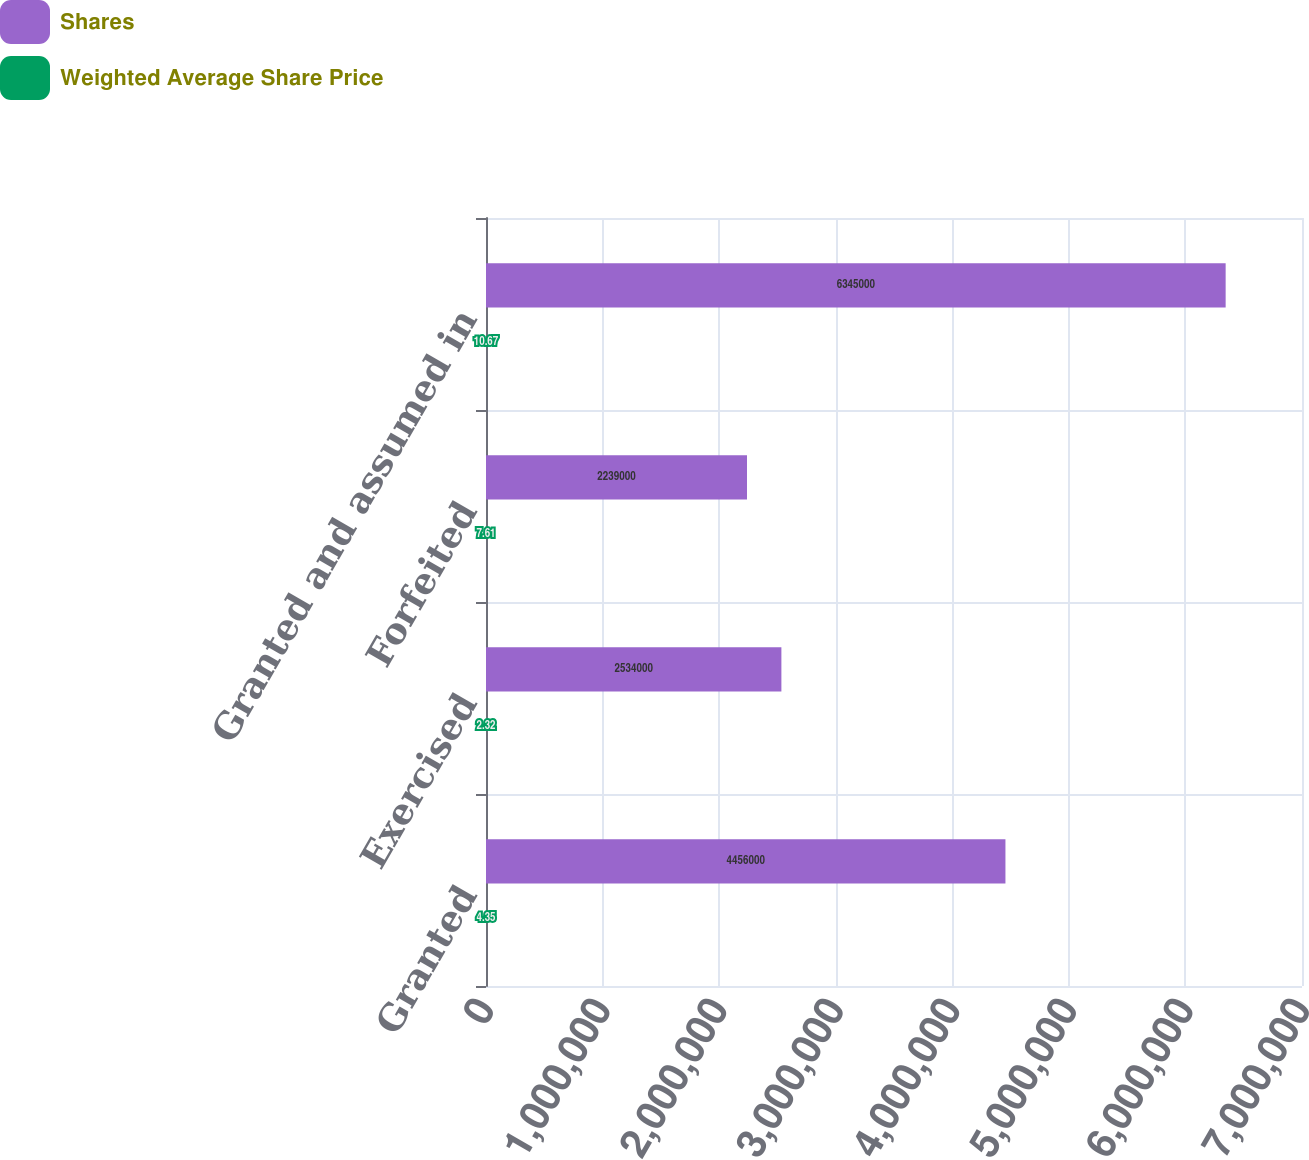<chart> <loc_0><loc_0><loc_500><loc_500><stacked_bar_chart><ecel><fcel>Granted<fcel>Exercised<fcel>Forfeited<fcel>Granted and assumed in<nl><fcel>Shares<fcel>4.456e+06<fcel>2.534e+06<fcel>2.239e+06<fcel>6.345e+06<nl><fcel>Weighted Average Share Price<fcel>4.35<fcel>2.32<fcel>7.61<fcel>10.67<nl></chart> 